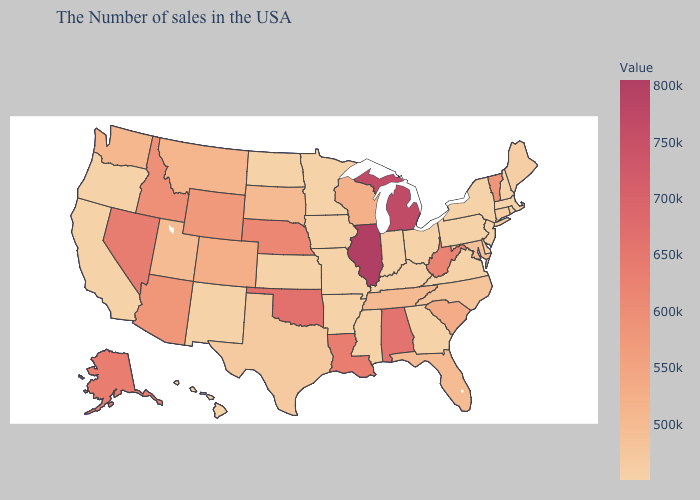Is the legend a continuous bar?
Concise answer only. Yes. Does South Dakota have a higher value than Vermont?
Answer briefly. No. Which states have the lowest value in the USA?
Keep it brief. Massachusetts, Rhode Island, New Hampshire, New York, New Jersey, Delaware, Pennsylvania, Virginia, Ohio, Georgia, Indiana, Mississippi, Missouri, Arkansas, Minnesota, Kansas, North Dakota, New Mexico, California, Oregon, Hawaii. Does the map have missing data?
Quick response, please. No. 